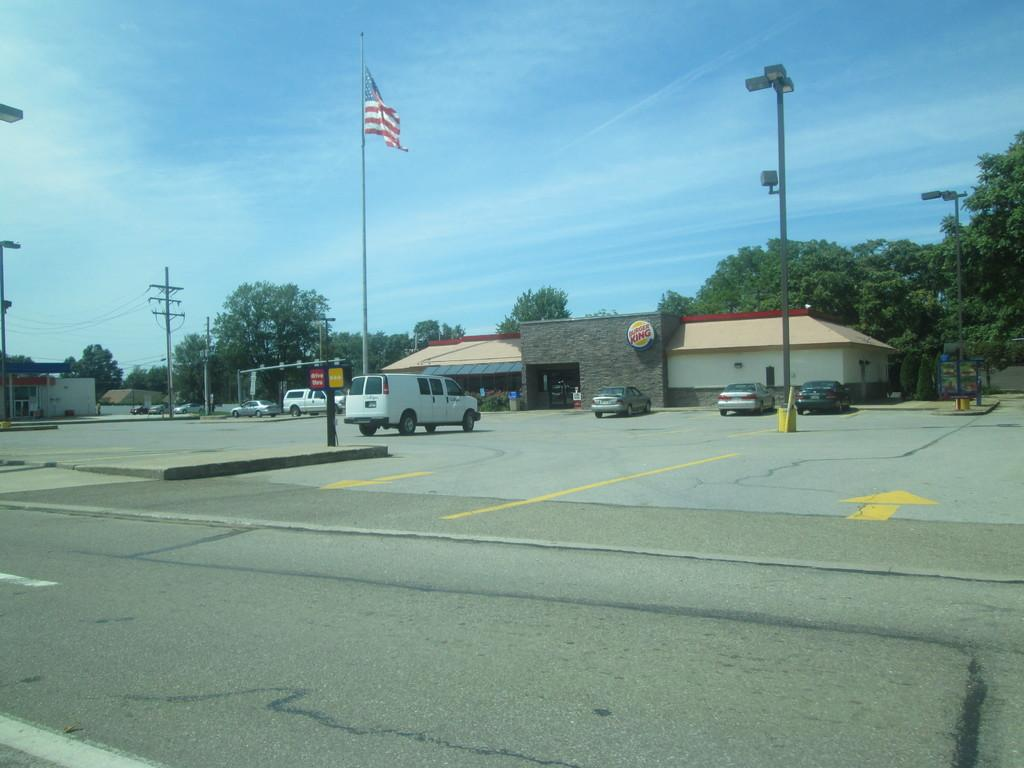What types of objects can be seen in the image? There are vehicles, electric poles, wires, signs, and light poles visible in the image. What is the setting of the image? The image shows a road with vehicles. What can be seen in the background of the image? In the background, there are trees and houses. What is the color of the sky in the image? The sky is blue in the image. What is being taught in the image? There is no indication of teaching or any educational activity in the image. What side of the road are the vehicles driving on in the image? The image does not provide information about which side of the road the vehicles are driving on. 